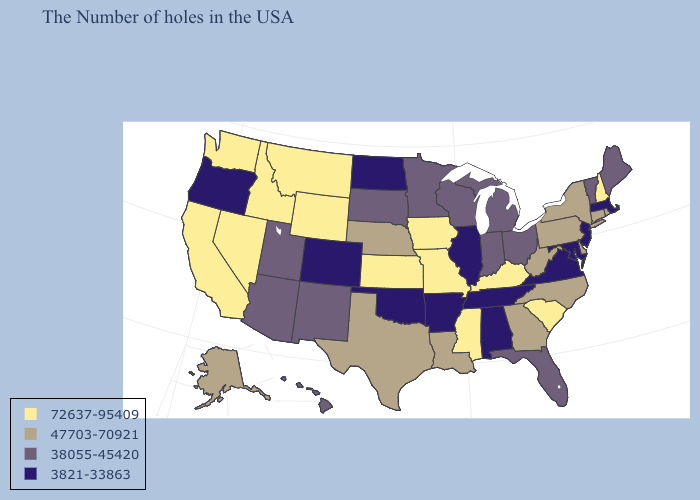What is the highest value in the Northeast ?
Quick response, please. 72637-95409. Name the states that have a value in the range 47703-70921?
Short answer required. Rhode Island, Connecticut, New York, Delaware, Pennsylvania, North Carolina, West Virginia, Georgia, Louisiana, Nebraska, Texas, Alaska. Name the states that have a value in the range 3821-33863?
Short answer required. Massachusetts, New Jersey, Maryland, Virginia, Alabama, Tennessee, Illinois, Arkansas, Oklahoma, North Dakota, Colorado, Oregon. Does California have the highest value in the USA?
Give a very brief answer. Yes. Name the states that have a value in the range 3821-33863?
Concise answer only. Massachusetts, New Jersey, Maryland, Virginia, Alabama, Tennessee, Illinois, Arkansas, Oklahoma, North Dakota, Colorado, Oregon. Which states have the lowest value in the Northeast?
Quick response, please. Massachusetts, New Jersey. Name the states that have a value in the range 3821-33863?
Write a very short answer. Massachusetts, New Jersey, Maryland, Virginia, Alabama, Tennessee, Illinois, Arkansas, Oklahoma, North Dakota, Colorado, Oregon. Does Alabama have the lowest value in the USA?
Answer briefly. Yes. What is the value of West Virginia?
Quick response, please. 47703-70921. What is the value of Illinois?
Be succinct. 3821-33863. Name the states that have a value in the range 47703-70921?
Be succinct. Rhode Island, Connecticut, New York, Delaware, Pennsylvania, North Carolina, West Virginia, Georgia, Louisiana, Nebraska, Texas, Alaska. Which states have the highest value in the USA?
Concise answer only. New Hampshire, South Carolina, Kentucky, Mississippi, Missouri, Iowa, Kansas, Wyoming, Montana, Idaho, Nevada, California, Washington. What is the value of Arizona?
Short answer required. 38055-45420. Does Oklahoma have a higher value than Nebraska?
Give a very brief answer. No. Name the states that have a value in the range 72637-95409?
Keep it brief. New Hampshire, South Carolina, Kentucky, Mississippi, Missouri, Iowa, Kansas, Wyoming, Montana, Idaho, Nevada, California, Washington. 